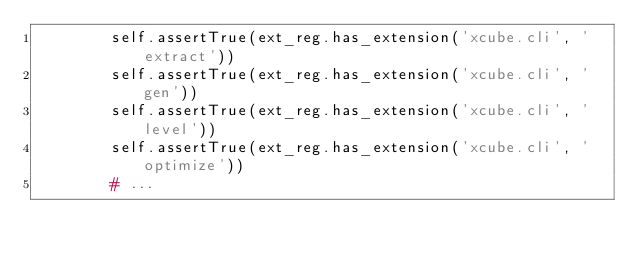<code> <loc_0><loc_0><loc_500><loc_500><_Python_>        self.assertTrue(ext_reg.has_extension('xcube.cli', 'extract'))
        self.assertTrue(ext_reg.has_extension('xcube.cli', 'gen'))
        self.assertTrue(ext_reg.has_extension('xcube.cli', 'level'))
        self.assertTrue(ext_reg.has_extension('xcube.cli', 'optimize'))
        # ...
</code> 